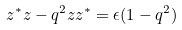<formula> <loc_0><loc_0><loc_500><loc_500>z ^ { \ast } z - q ^ { 2 } z z ^ { \ast } = \epsilon ( 1 - q ^ { 2 } )</formula> 